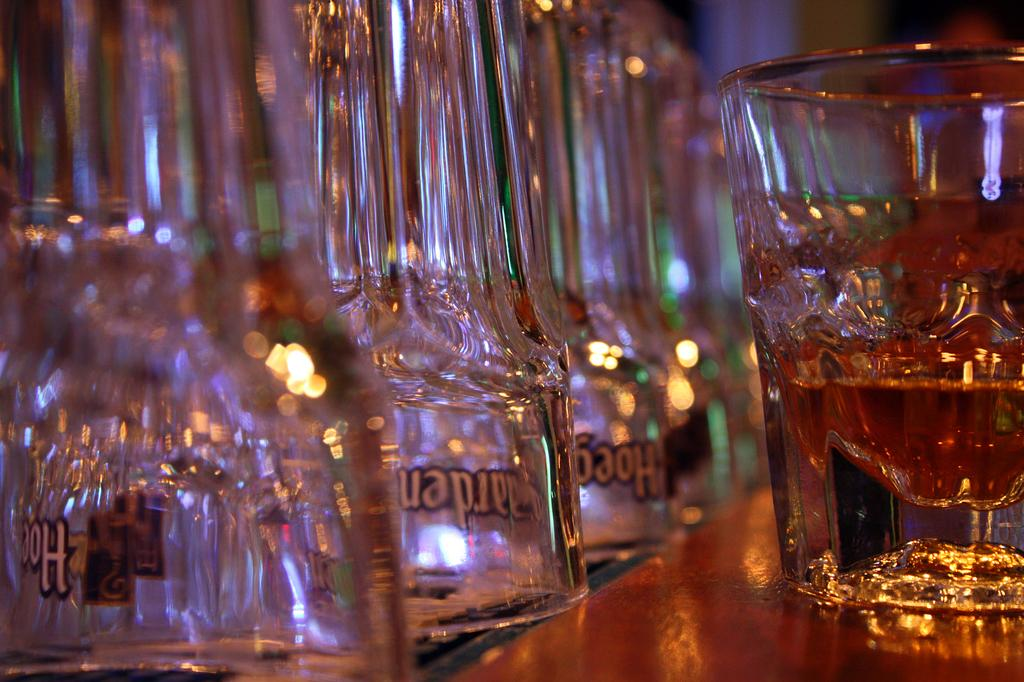What is inside the glass that is visible in the image? There is a drink in the glass that is visible in the image. How many glasses can be seen in the image? There are additional glasses in the image. Where are the glasses placed? The glasses are placed on a platform. What type of pipe is visible in the image? There is no pipe present in the image. How many shades of color can be seen on the glasses in the image? The glasses in the image are not described as having different shades of color. 